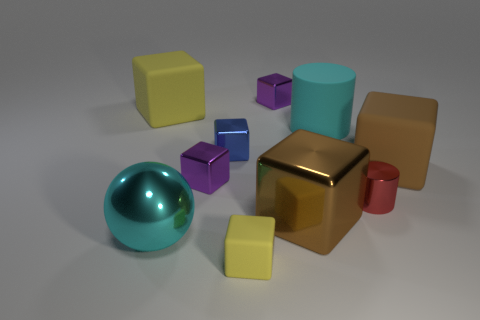Subtract all purple blocks. How many blocks are left? 5 Subtract 2 blocks. How many blocks are left? 5 Subtract all big brown metallic blocks. How many blocks are left? 6 Subtract all red cubes. Subtract all purple cylinders. How many cubes are left? 7 Subtract all spheres. How many objects are left? 9 Subtract all yellow rubber blocks. Subtract all tiny red things. How many objects are left? 7 Add 4 large yellow objects. How many large yellow objects are left? 5 Add 3 yellow rubber cubes. How many yellow rubber cubes exist? 5 Subtract 2 brown blocks. How many objects are left? 8 